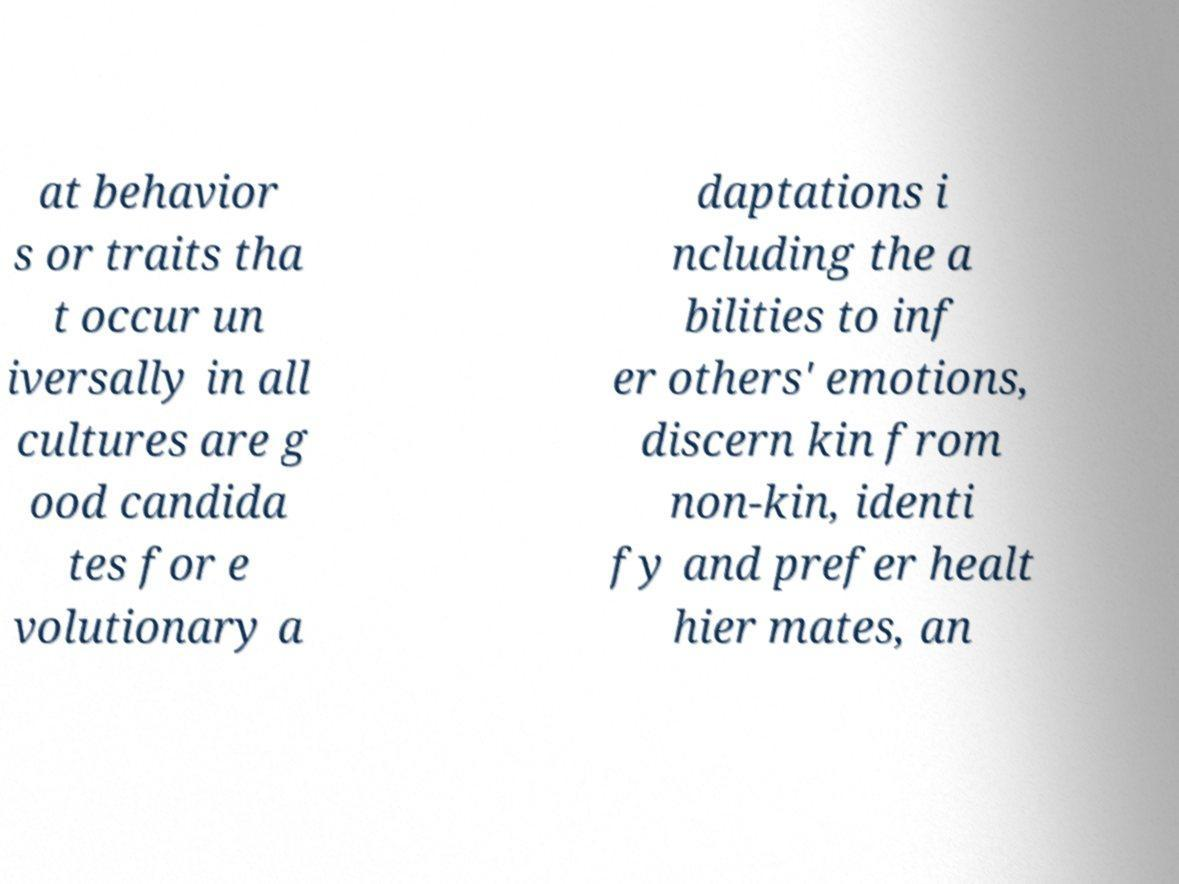Please identify and transcribe the text found in this image. at behavior s or traits tha t occur un iversally in all cultures are g ood candida tes for e volutionary a daptations i ncluding the a bilities to inf er others' emotions, discern kin from non-kin, identi fy and prefer healt hier mates, an 